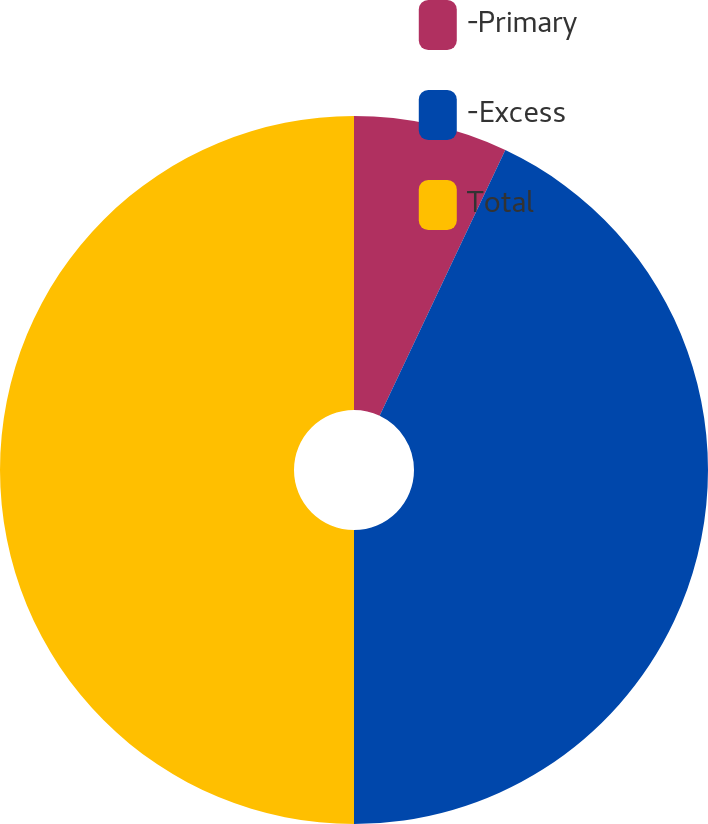<chart> <loc_0><loc_0><loc_500><loc_500><pie_chart><fcel>-Primary<fcel>-Excess<fcel>Total<nl><fcel>7.03%<fcel>42.97%<fcel>50.0%<nl></chart> 